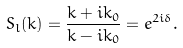Convert formula to latex. <formula><loc_0><loc_0><loc_500><loc_500>S _ { l } ( k ) = \frac { k + i k _ { 0 } } { k - i k _ { 0 } } = e ^ { 2 i \delta } .</formula> 